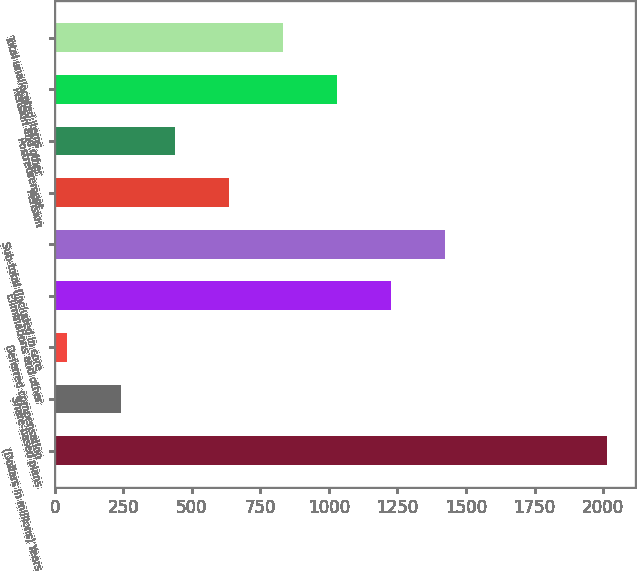Convert chart. <chart><loc_0><loc_0><loc_500><loc_500><bar_chart><fcel>(Dollars in millions) Years<fcel>Share-based plans<fcel>Deferred compensation<fcel>Eliminations and other<fcel>Sub-total (included in core<fcel>Pension<fcel>Postretirement<fcel>Pension and other<fcel>Total unallocated items<nl><fcel>2016<fcel>243<fcel>46<fcel>1228<fcel>1425<fcel>637<fcel>440<fcel>1031<fcel>834<nl></chart> 